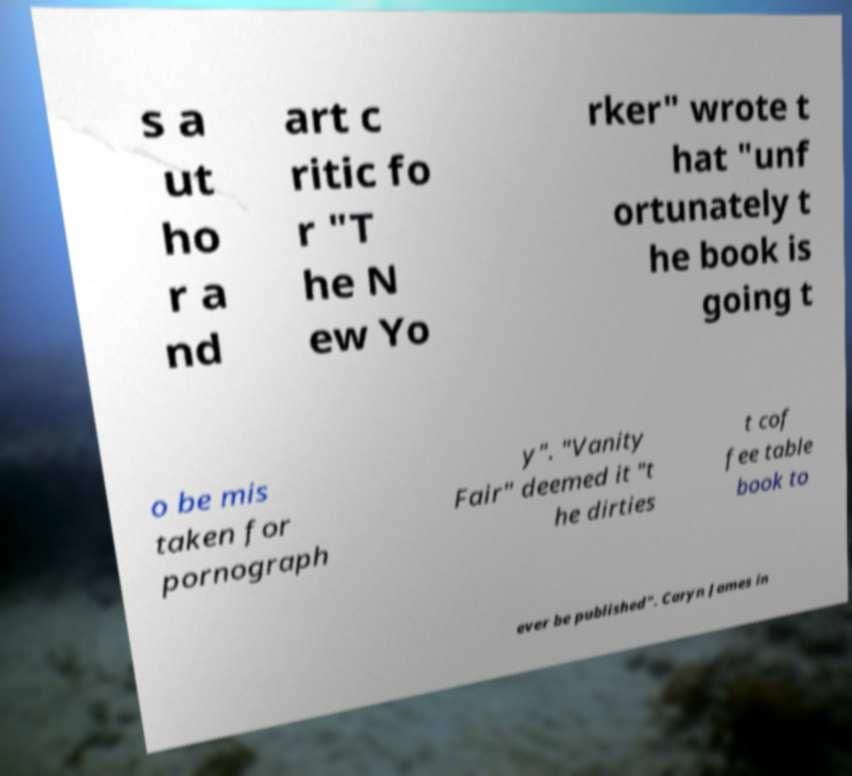What messages or text are displayed in this image? I need them in a readable, typed format. s a ut ho r a nd art c ritic fo r "T he N ew Yo rker" wrote t hat "unf ortunately t he book is going t o be mis taken for pornograph y". "Vanity Fair" deemed it "t he dirties t cof fee table book to ever be published". Caryn James in 